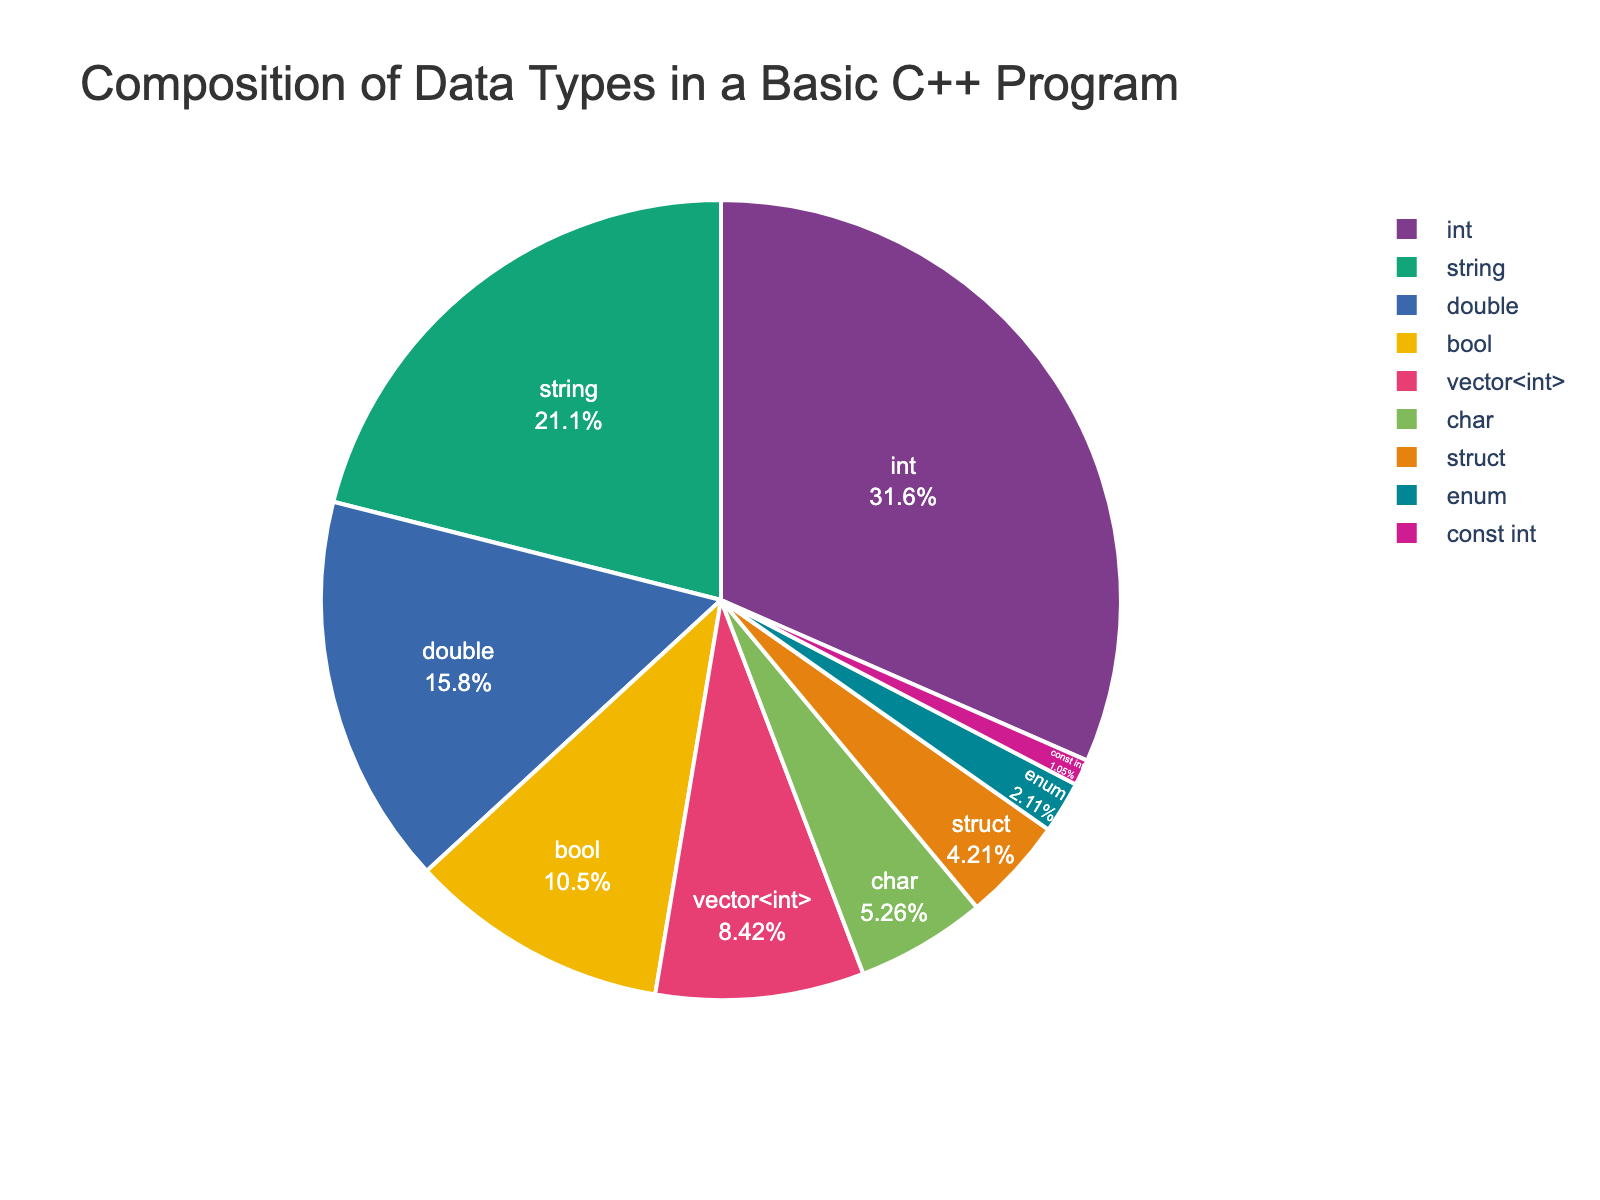What is the most commonly used data type in the pie chart? The pie chart shows various data types with their usage percentages. The largest segment visually represents the most commonly used data type. Here, the "int" segment is the largest, indicating it's the most frequently used.
Answer: int What is the combined percentage of "char" and "bool" data types? To find the combined percentage, sum the individual percentages of "char" (5) and "bool" (10). This gives 5 + 10 = 15.
Answer: 15 Which data type has a larger usage percentage: "double" or "string"? By comparing the segments of the pie chart, we see that the percentage for "string" (20%) is larger than that for "double" (15%).
Answer: string How much more percentage is used by "int" compared to "vector<int>"? The "int" data type has a percentage of 30, while "vector<int>" has 8. To find the difference: 30 - 8 = 22.
Answer: 22 What is the average percentage of the "struct", "enum", and "const int" data types? First, sum the percentages of these data types: 4 (struct) + 2 (enum) + 1 (const int) = 7. Then, divide by the number of data types: 7 / 3 ≈ 2.33.
Answer: 2.33 Which segment appears to be the smallest in the pie chart? The pie chart shows that "const int" has the smallest segment with a percentage of 1.
Answer: const int What is the percentage difference between the most and least used data types? The "int" data type has the highest usage at 30%, and "const int" has the lowest at 1%. The difference is 30 - 1 = 29.
Answer: 29 If "int" and "double" percentages are combined, what is their total? By adding the "int" (30) and "double" (15) percentages, we get 30 + 15 = 45.
Answer: 45 